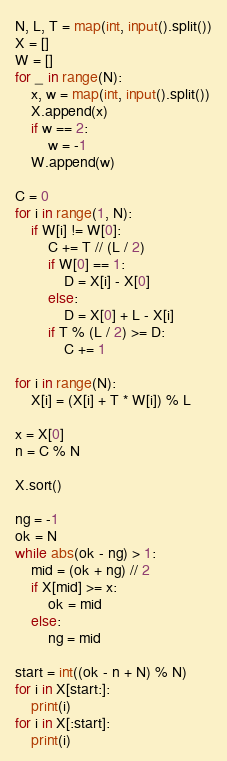<code> <loc_0><loc_0><loc_500><loc_500><_Python_>N, L, T = map(int, input().split())
X = []
W = []
for _ in range(N):
    x, w = map(int, input().split())
    X.append(x)
    if w == 2:
        w = -1
    W.append(w)

C = 0
for i in range(1, N):
    if W[i] != W[0]:
        C += T // (L / 2)
        if W[0] == 1:
            D = X[i] - X[0]
        else:
            D = X[0] + L - X[i]
        if T % (L / 2) >= D:
            C += 1

for i in range(N):
    X[i] = (X[i] + T * W[i]) % L

x = X[0]
n = C % N

X.sort()

ng = -1
ok = N
while abs(ok - ng) > 1:
    mid = (ok + ng) // 2
    if X[mid] >= x:
        ok = mid
    else:
        ng = mid

start = int((ok - n + N) % N)
for i in X[start:]:
    print(i)
for i in X[:start]:
    print(i)</code> 